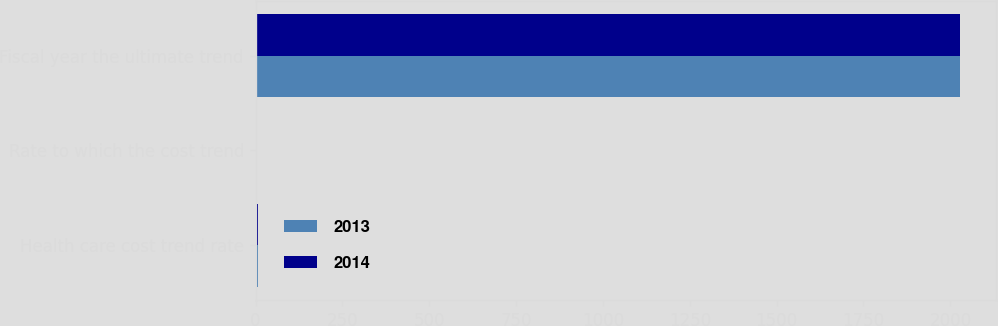Convert chart to OTSL. <chart><loc_0><loc_0><loc_500><loc_500><stacked_bar_chart><ecel><fcel>Health care cost trend rate<fcel>Rate to which the cost trend<fcel>Fiscal year the ultimate trend<nl><fcel>2013<fcel>7.01<fcel>4.5<fcel>2029<nl><fcel>2014<fcel>7.33<fcel>4.5<fcel>2029<nl></chart> 